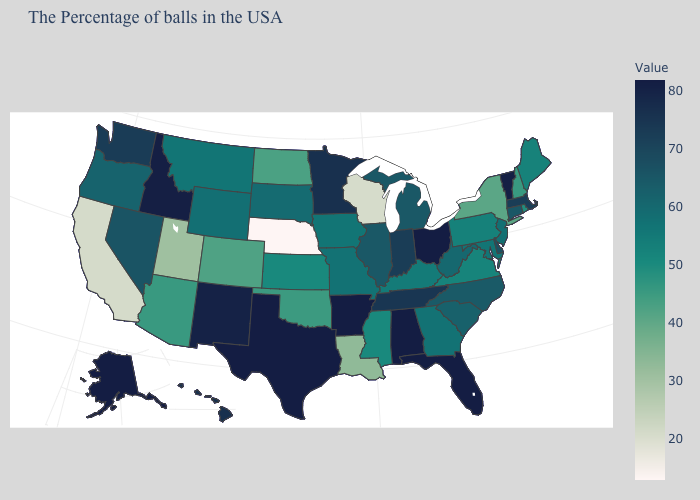Does Nebraska have the lowest value in the USA?
Quick response, please. Yes. Which states hav the highest value in the MidWest?
Write a very short answer. Ohio. Which states hav the highest value in the West?
Concise answer only. Alaska. Does Utah have a higher value than California?
Be succinct. Yes. Among the states that border Alabama , which have the lowest value?
Concise answer only. Mississippi. Does New York have a higher value than California?
Concise answer only. Yes. Does Nebraska have the lowest value in the USA?
Keep it brief. Yes. 